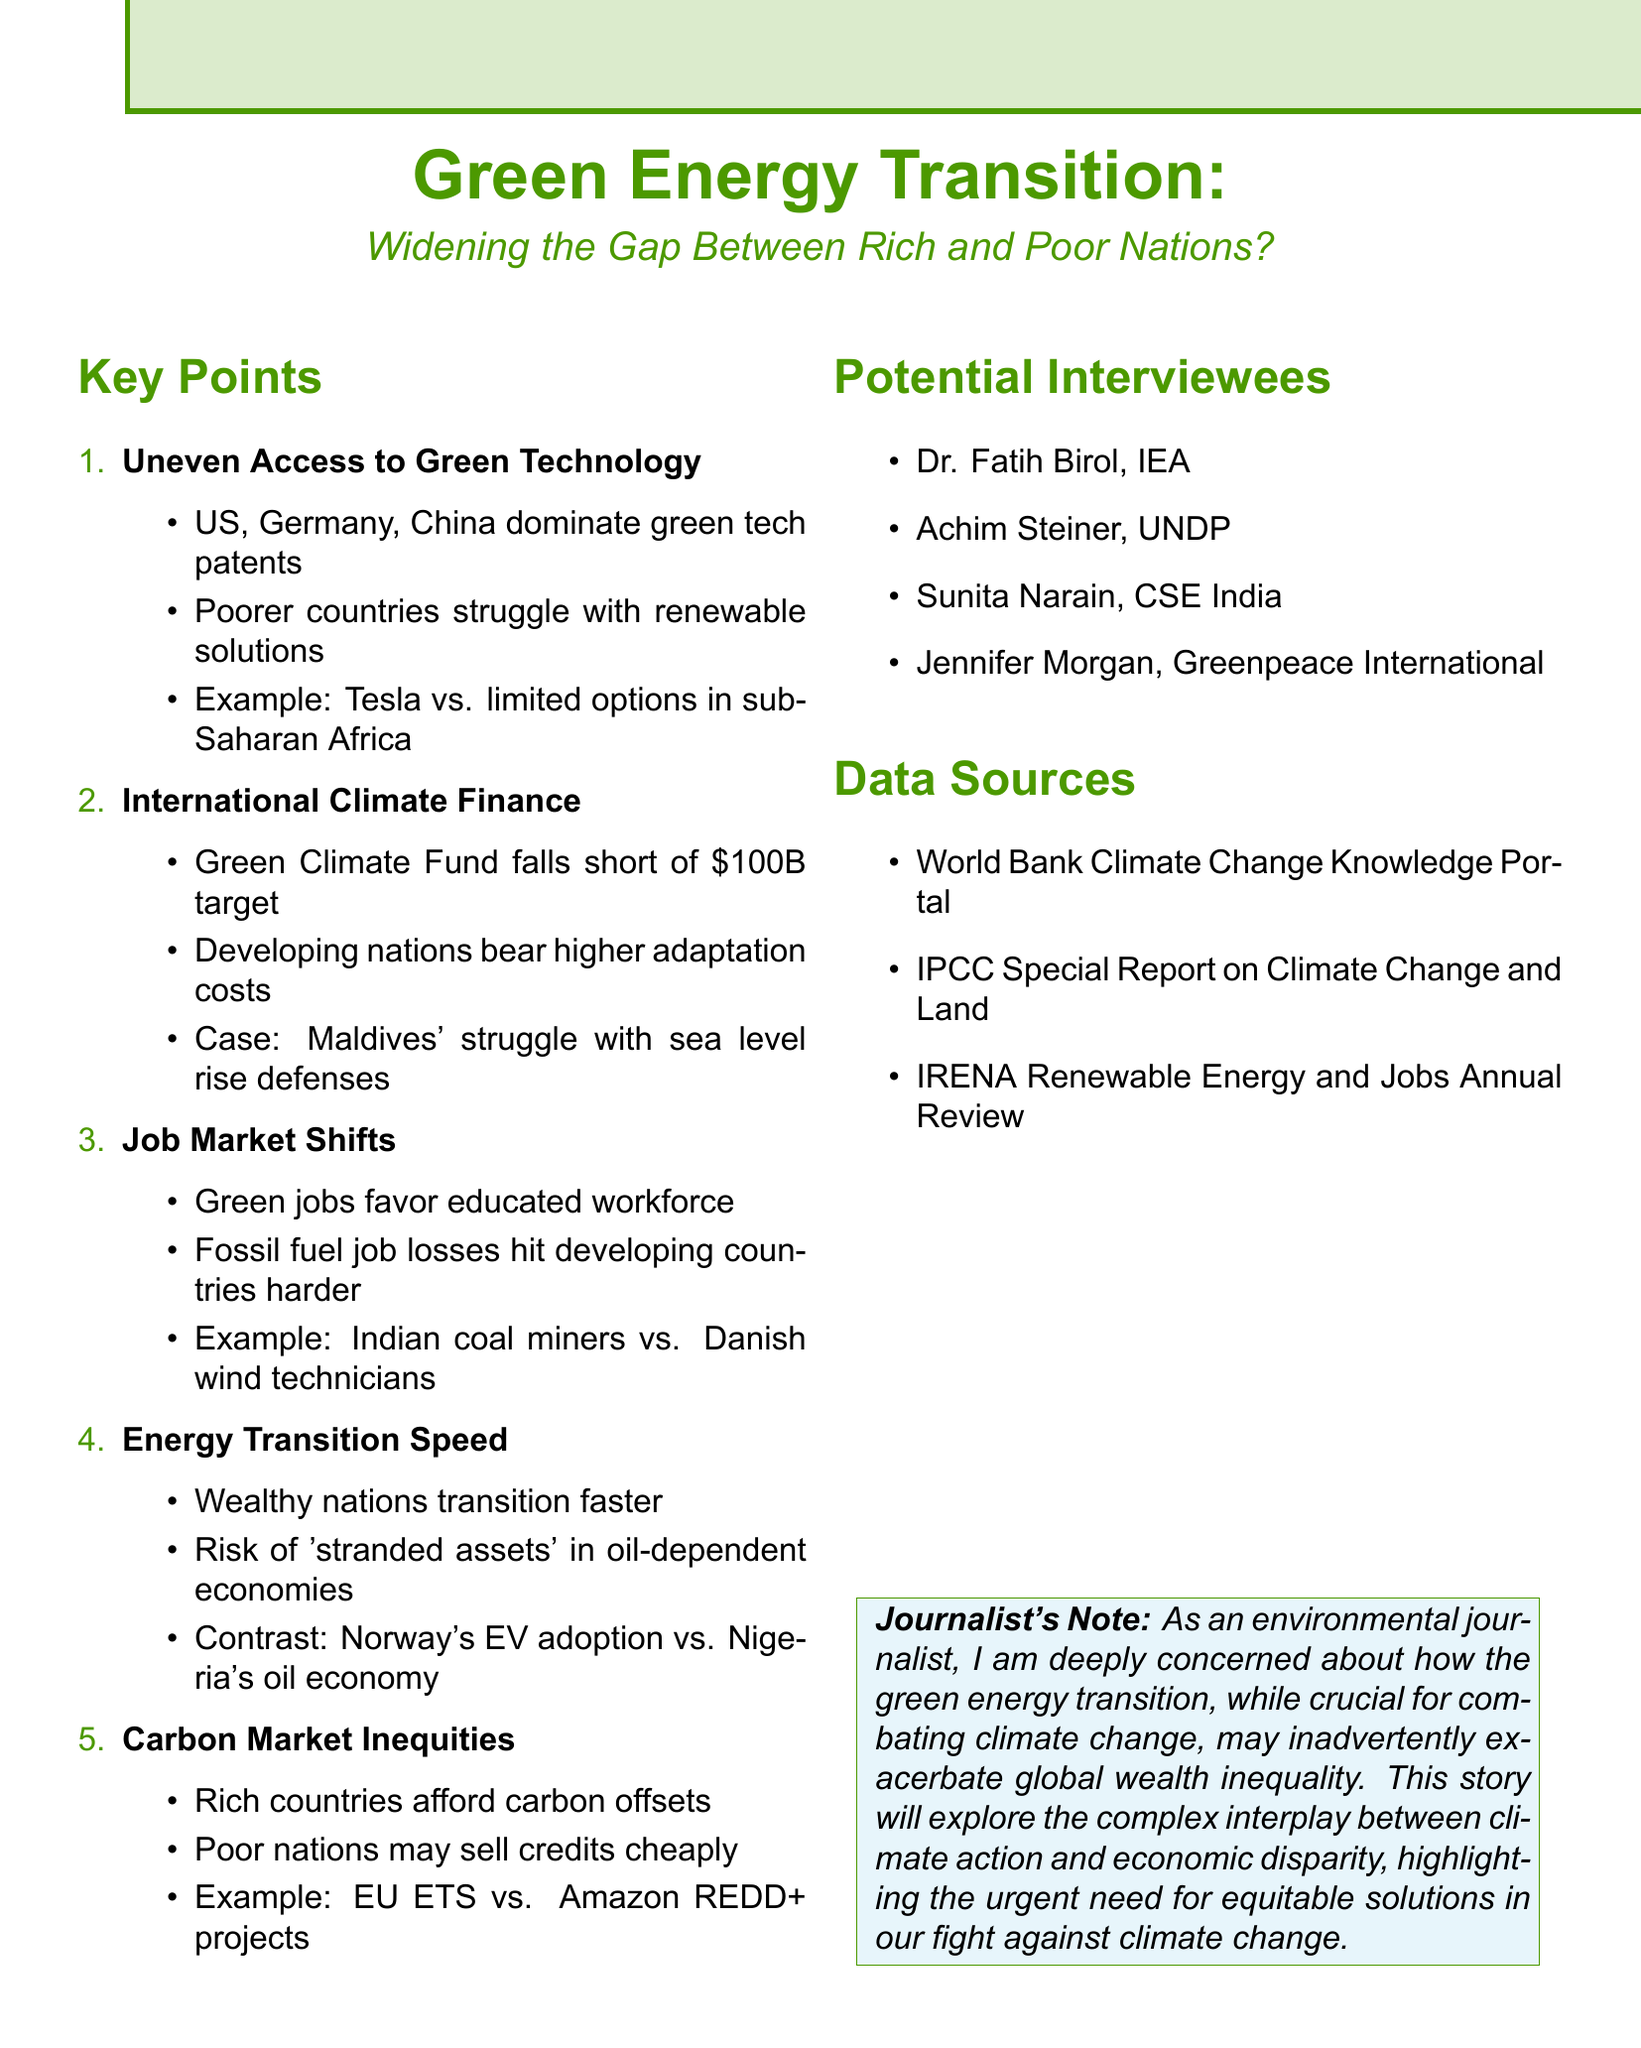What is the annual target for the Green Climate Fund? The document states that the Green Climate Fund pledges fall short of the target, which is $100 billion annually.
Answer: $100 billion Which countries dominate green tech patents? The document mentions specific countries that lead in green tech patents, including the US, Germany, and China.
Answer: US, Germany, China What issue is highlighted in relation to fossil fuel industry job losses? The document points out that fossil fuel job losses impact developing countries more significantly.
Answer: Developing countries What is a potential risk for countries that rely on fossil fuels? The document explains the risk of 'stranded assets' for economies dependent on fossil fuels.
Answer: Stranded assets Who is listed as an interviewee from Greenpeace International? The document includes potential interviewees, one of whom is Jennifer Morgan from Greenpeace International.
Answer: Jennifer Morgan Which case study is provided regarding international climate finance? The Maldives' struggle to fund sea level rise defenses is mentioned as a case study related to climate finance.
Answer: Maldives What technological solution is contrasted between Tesla and sub-Saharan Africa? The document contrasts Tesla's solar roof tiles against the limited solar options available in sub-Saharan Africa.
Answer: Tesla's solar roof tiles What is one of the data sources mentioned in the document? The document lists several data sources, including the World Bank Climate Change Knowledge Portal.
Answer: World Bank Climate Change Knowledge Portal What does the document state about the speed of energy transitions between wealthy and poor nations? The document indicates that wealthy nations can transition to green energy faster than poorer nations.
Answer: Faster transition 